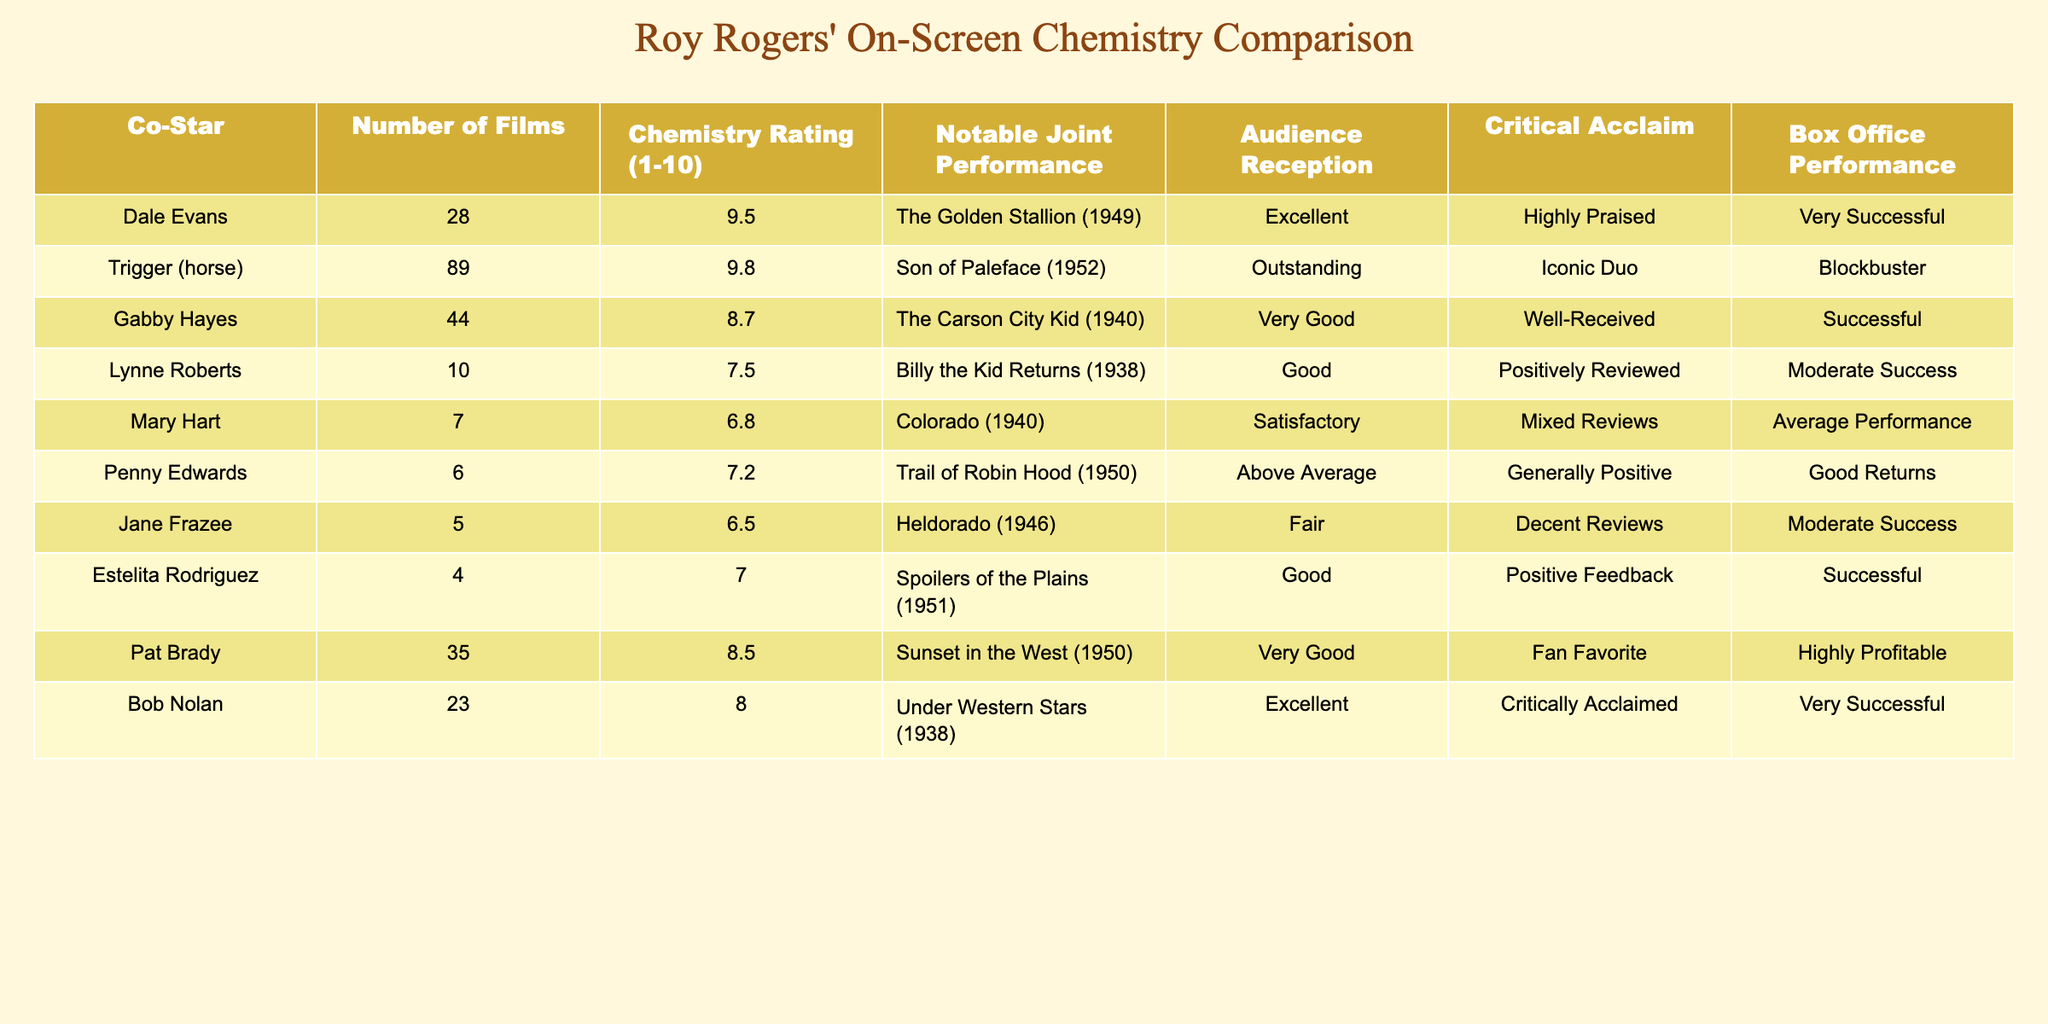What is the chemistry rating of Roy Rogers when paired with Dale Evans? The table indicates that the chemistry rating for Roy Rogers and Dale Evans is 9.5. This value is directly provided in the corresponding column for Dale Evans.
Answer: 9.5 Which co-star has the highest chemistry rating with Roy Rogers? According to the chemistry ratings in the table, Trigger (the horse) has the highest rating of 9.8. This is the maximum value listed in the Chemistry Rating column.
Answer: 9.8 Is the audience reception for movies featuring Trigger categorized as outstanding? Yes, the audience reception for movies featuring Trigger is classified as outstanding based on the corresponding data in the table. This confirms that the audience had a very positive view of these pairings.
Answer: Yes What is the average chemistry rating for all co-stars who appeared in more than 10 films with Roy Rogers? The co-stars with more than 10 films are Dale Evans, Gabby Hayes, Pat Brady, and Bob Nolan. Their chemistry ratings are 9.5, 8.7, 8.5, and 8.0, respectively. The average is calculated as (9.5 + 8.7 + 8.5 + 8.0) / 4 = 8.675.
Answer: 8.675 Did Lynne Roberts and Roy Rogers have a notable joint performance recognized by audience reception? No, Lynne Roberts' notable joint performance, "Billy the Kid Returns," is described as having a 'Good' reception, which is lower than 'Very Good' or 'Excellent', indicating that the joint performance did not achieve a high reception level.
Answer: No Which co-stars had a chemistry rating lower than 7.0 and what was their audience reception? Only Mary Hart had a chemistry rating lower than 7.0, with a chemistry rating of 6.8 and an audience reception categorized as 'Satisfactory'. This directly corresponds to the data presented in the table and satisfies the condition of the question.
Answer: Mary Hart, Satisfactory What is the total number of films featuring Roy Rogers and his co-stars with a chemistry rating above 8.0? The co-stars with a chemistry rating above 8.0 are Dale Evans (28 films), Trigger (89 films), Gabby Hayes (44 films), Pat Brady (35 films), and Bob Nolan (23 films). Summing these gives 28 + 89 + 44 + 35 + 23 = 219 films.
Answer: 219 How many films did Penny Edwards appear in with Roy Rogers? According to the table, Penny Edwards appeared in 6 films with Roy Rogers, which is documented in the Number of Films column associated with her name.
Answer: 6 What notable performance did Gabby Hayes have alongside Roy Rogers? Gabby Hayes’ notable joint performance with Roy Rogers is identified in the table as "The Carson City Kid" (1940). This detail is specifically noted in the Notable Joint Performance column.
Answer: The Carson City Kid (1940) 